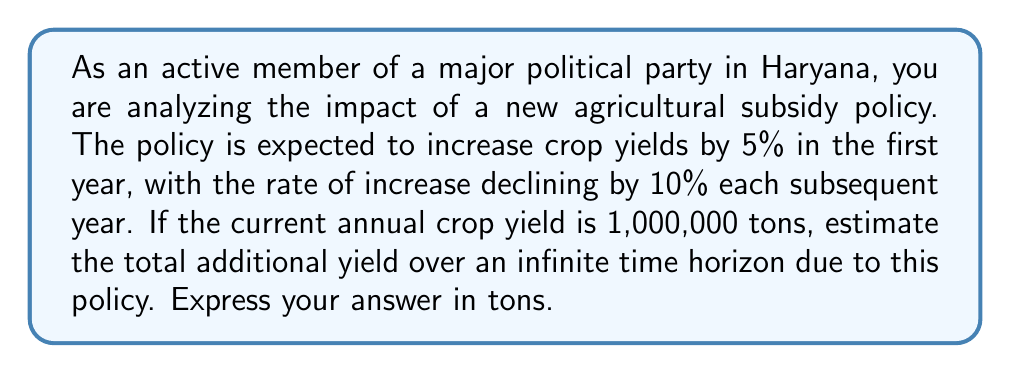Can you answer this question? Let's approach this step-by-step using an infinite geometric series:

1) Let $a$ be the first term and $r$ be the common ratio of the geometric series.

2) In the first year, the increase is 5% of 1,000,000 tons:
   $a = 0.05 \times 1,000,000 = 50,000$ tons

3) Each year, the rate of increase declines by 10% of the previous year's rate:
   $r = 1 - 0.10 = 0.90$

4) The series representing the additional yield each year is:
   $50,000 + 50,000(0.90) + 50,000(0.90)^2 + 50,000(0.90)^3 + ...$

5) This is an infinite geometric series with $|r| < 1$, so we can use the formula:
   $S_{\infty} = \frac{a}{1-r}$

6) Substituting our values:
   $S_{\infty} = \frac{50,000}{1-0.90} = \frac{50,000}{0.10} = 500,000$

Therefore, the total additional yield over an infinite time horizon is 500,000 tons.
Answer: 500,000 tons 